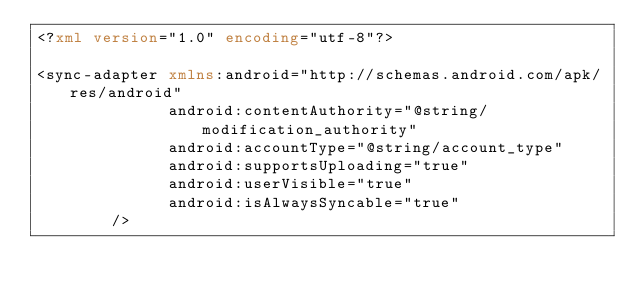<code> <loc_0><loc_0><loc_500><loc_500><_XML_><?xml version="1.0" encoding="utf-8"?>

<sync-adapter xmlns:android="http://schemas.android.com/apk/res/android"
              android:contentAuthority="@string/modification_authority"
              android:accountType="@string/account_type"
              android:supportsUploading="true"
              android:userVisible="true"
              android:isAlwaysSyncable="true"
        />
</code> 